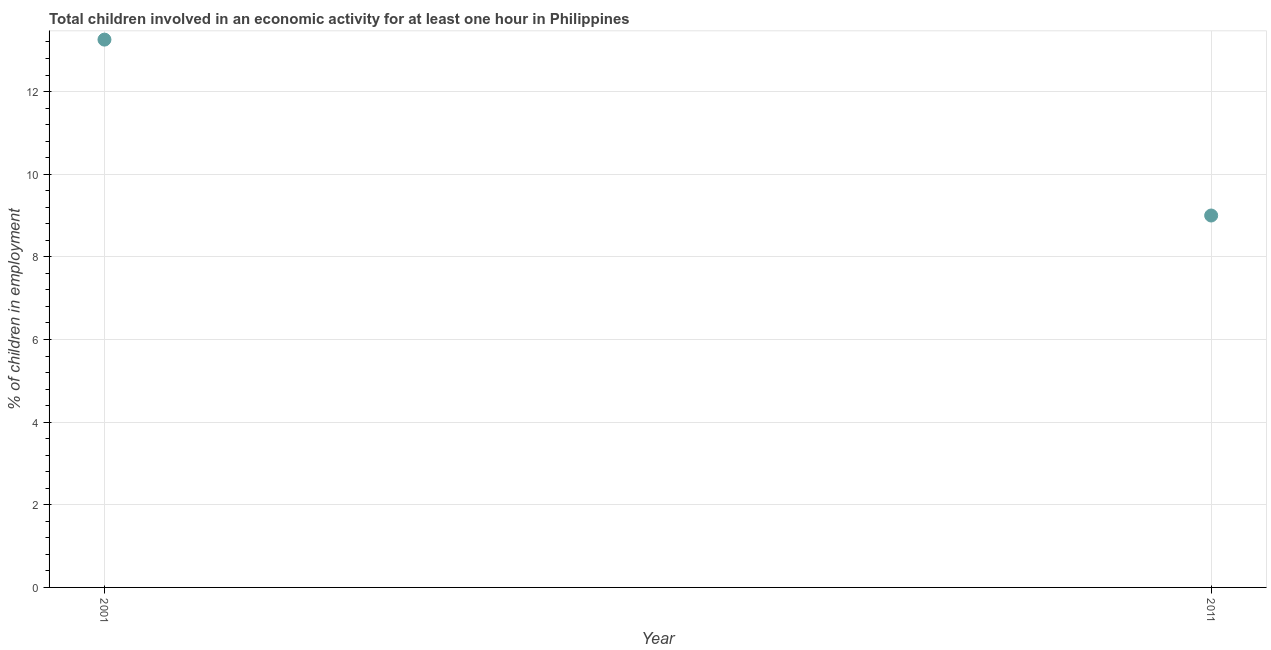What is the percentage of children in employment in 2001?
Make the answer very short. 13.26. Across all years, what is the maximum percentage of children in employment?
Provide a succinct answer. 13.26. In which year was the percentage of children in employment maximum?
Your answer should be compact. 2001. In which year was the percentage of children in employment minimum?
Provide a short and direct response. 2011. What is the sum of the percentage of children in employment?
Keep it short and to the point. 22.26. What is the difference between the percentage of children in employment in 2001 and 2011?
Keep it short and to the point. 4.26. What is the average percentage of children in employment per year?
Give a very brief answer. 11.13. What is the median percentage of children in employment?
Your answer should be compact. 11.13. In how many years, is the percentage of children in employment greater than 7.2 %?
Your response must be concise. 2. What is the ratio of the percentage of children in employment in 2001 to that in 2011?
Give a very brief answer. 1.47. In how many years, is the percentage of children in employment greater than the average percentage of children in employment taken over all years?
Make the answer very short. 1. How many dotlines are there?
Your answer should be very brief. 1. What is the difference between two consecutive major ticks on the Y-axis?
Make the answer very short. 2. Are the values on the major ticks of Y-axis written in scientific E-notation?
Give a very brief answer. No. Does the graph contain grids?
Your answer should be compact. Yes. What is the title of the graph?
Make the answer very short. Total children involved in an economic activity for at least one hour in Philippines. What is the label or title of the X-axis?
Offer a very short reply. Year. What is the label or title of the Y-axis?
Offer a very short reply. % of children in employment. What is the % of children in employment in 2001?
Offer a very short reply. 13.26. What is the difference between the % of children in employment in 2001 and 2011?
Offer a terse response. 4.26. What is the ratio of the % of children in employment in 2001 to that in 2011?
Keep it short and to the point. 1.47. 